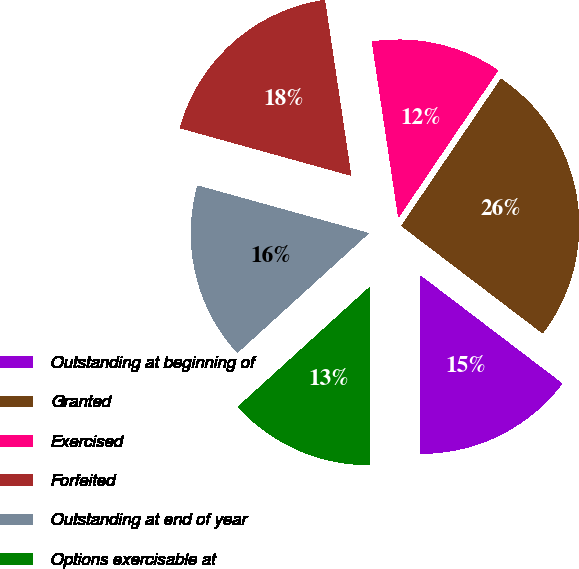<chart> <loc_0><loc_0><loc_500><loc_500><pie_chart><fcel>Outstanding at beginning of<fcel>Granted<fcel>Exercised<fcel>Forfeited<fcel>Outstanding at end of year<fcel>Options exercisable at<nl><fcel>14.65%<fcel>25.88%<fcel>11.84%<fcel>18.32%<fcel>16.06%<fcel>13.25%<nl></chart> 